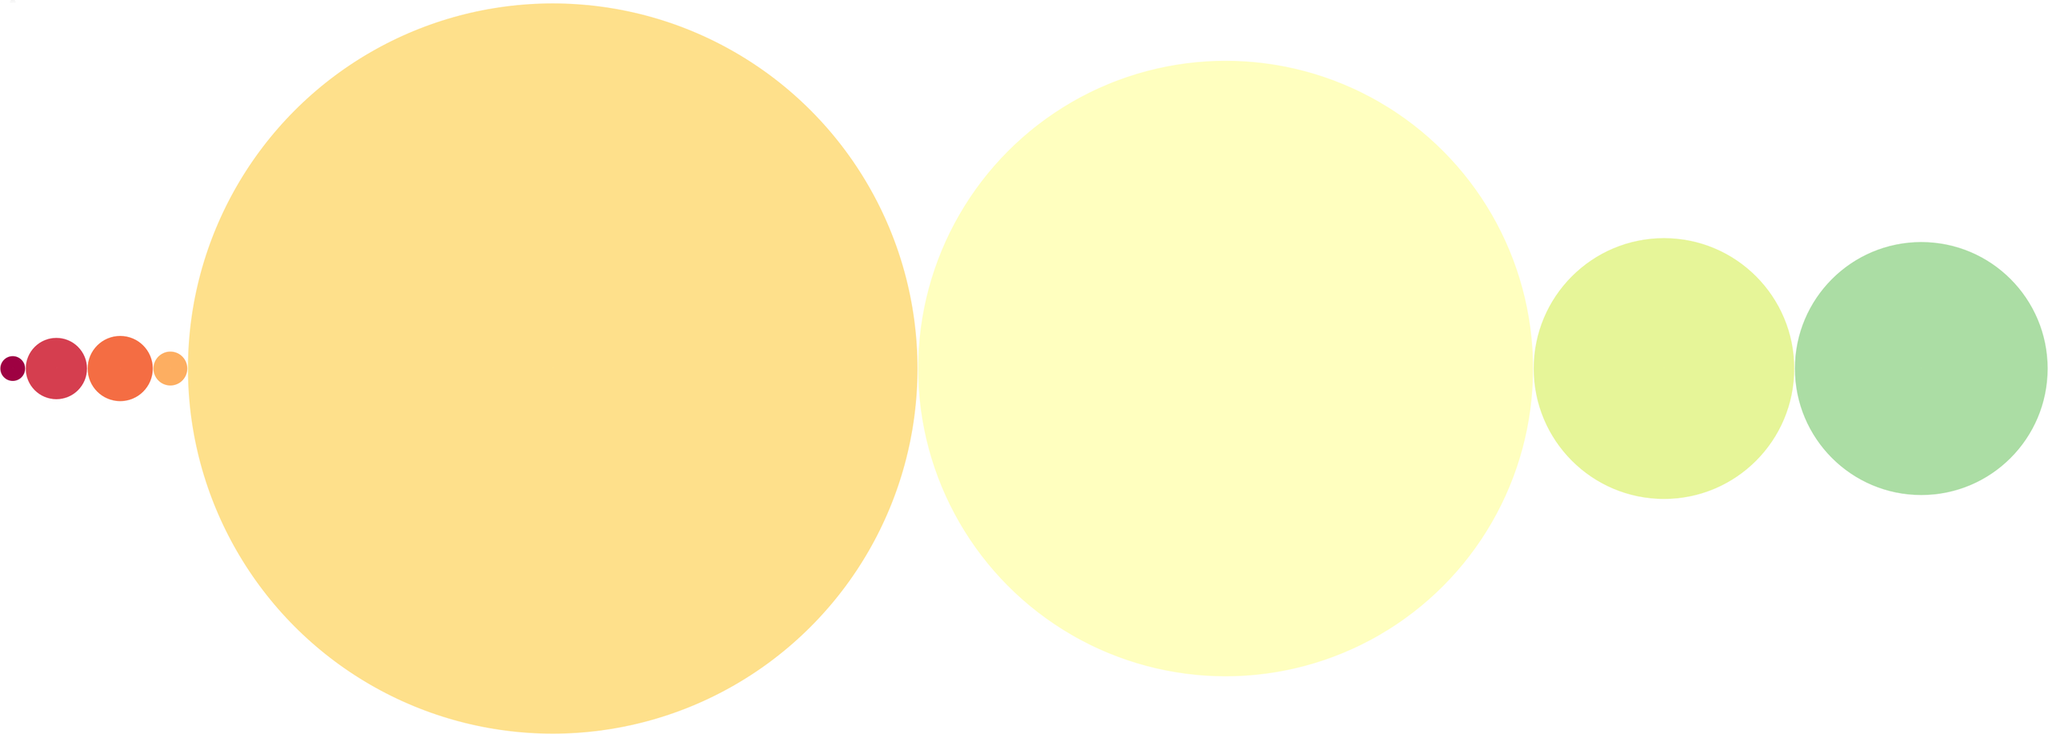What is the size ratio of Jupiter compared to Mercury? Jupiter has a relative size of 11.2, while Mercury has a relative size of 0.38. To find the size ratio, divide the size of Jupiter by the size of Mercury: 11.2 / 0.38 = 29.47. Therefore, Jupiter is approximately 29.47 times larger than Mercury.
Answer: 29.47 Which planet is the fifth in order from the Sun? The diagram lists the planets in order from 1 to 8. Counting from Mercury (1), Venus (2), Earth (3), Mars (4), the fifth planet is Jupiter.
Answer: Jupiter How many planets are depicted in this diagram? The diagram shows eight planets: Mercury, Venus, Earth, Mars, Jupiter, Saturn, Uranus, and Neptune. By counting each planet listed under "planets," we find a total of eight planets.
Answer: Eight What is the mnemonic provided for remembering the order of the planets? The diagram includes a mnemonic at the bottom labeled "Mnemonic." It states, "My Very Educated Mother Just Served Us Noodles," which is a popular phrase used to remember the order of the planets from the Sun.
Answer: My Very Educated Mother Just Served Us Noodles What is a cost-effective way to create a model of the solar system? The diagram lists several budget-friendly tips, one of which suggests creating a paper model using free printables. This is a practical method that requires little to no cost.
Answer: Create a paper model using free printables Which planet has a relative size closest to one? Earth has a relative size of 1, making it the planet depicted in the diagram that is equal in size to the reference unit. All other planets' relative sizes are compared to Earth's unit size of 1.
Answer: Earth How does the size of Saturn compare to that of Neptune? Saturn has a relative size of 9.45, while Neptune has a relative size of 3.88. By comparing these values, we can see that Saturn is larger than Neptune, specifically about 2.43 times larger (9.45 / 3.88).
Answer: Saturn is larger What number represents the order of Mars in the solar system lineup? Mars is listed as number 4 in order from the Sun among the planets shown in the diagram.
Answer: Four 